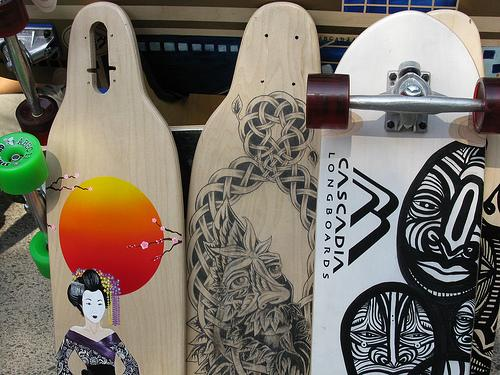What type of floor is depicted in the image? The floor is made of ceramic. Identify the primary color of the circle in the image. The circle is primarily orange. Point out a design element of the black and white longboard. The black and white longboard has a logo on the bottom. What does the black text on the bottom of the longboard say? The black letters say "cascadia" and "longboard." State the ethnicity of the woman shown in the image. The woman is Japanese. Which type of metal is the bar made of? The bar is made of metallic material. Describe a unique feature of the skateboard with the leaf man face. The skateboard with the leaf man face has maroon wheels and silver trucks. Please describe the decorations on the skateboards. The skateboards are decorated with illustrations in black paint, including faces, cherry blossom branches, and a painted sun. What kind of wheels are on the green skateboard? The skateboard has green wheels and silver trucks. What type of woman is depicted on the skateboard? A Japanese woman is depicted on the skateboard. The cherry blossom branch painted on the skateboard is upside down. No, it's not mentioned in the image. 